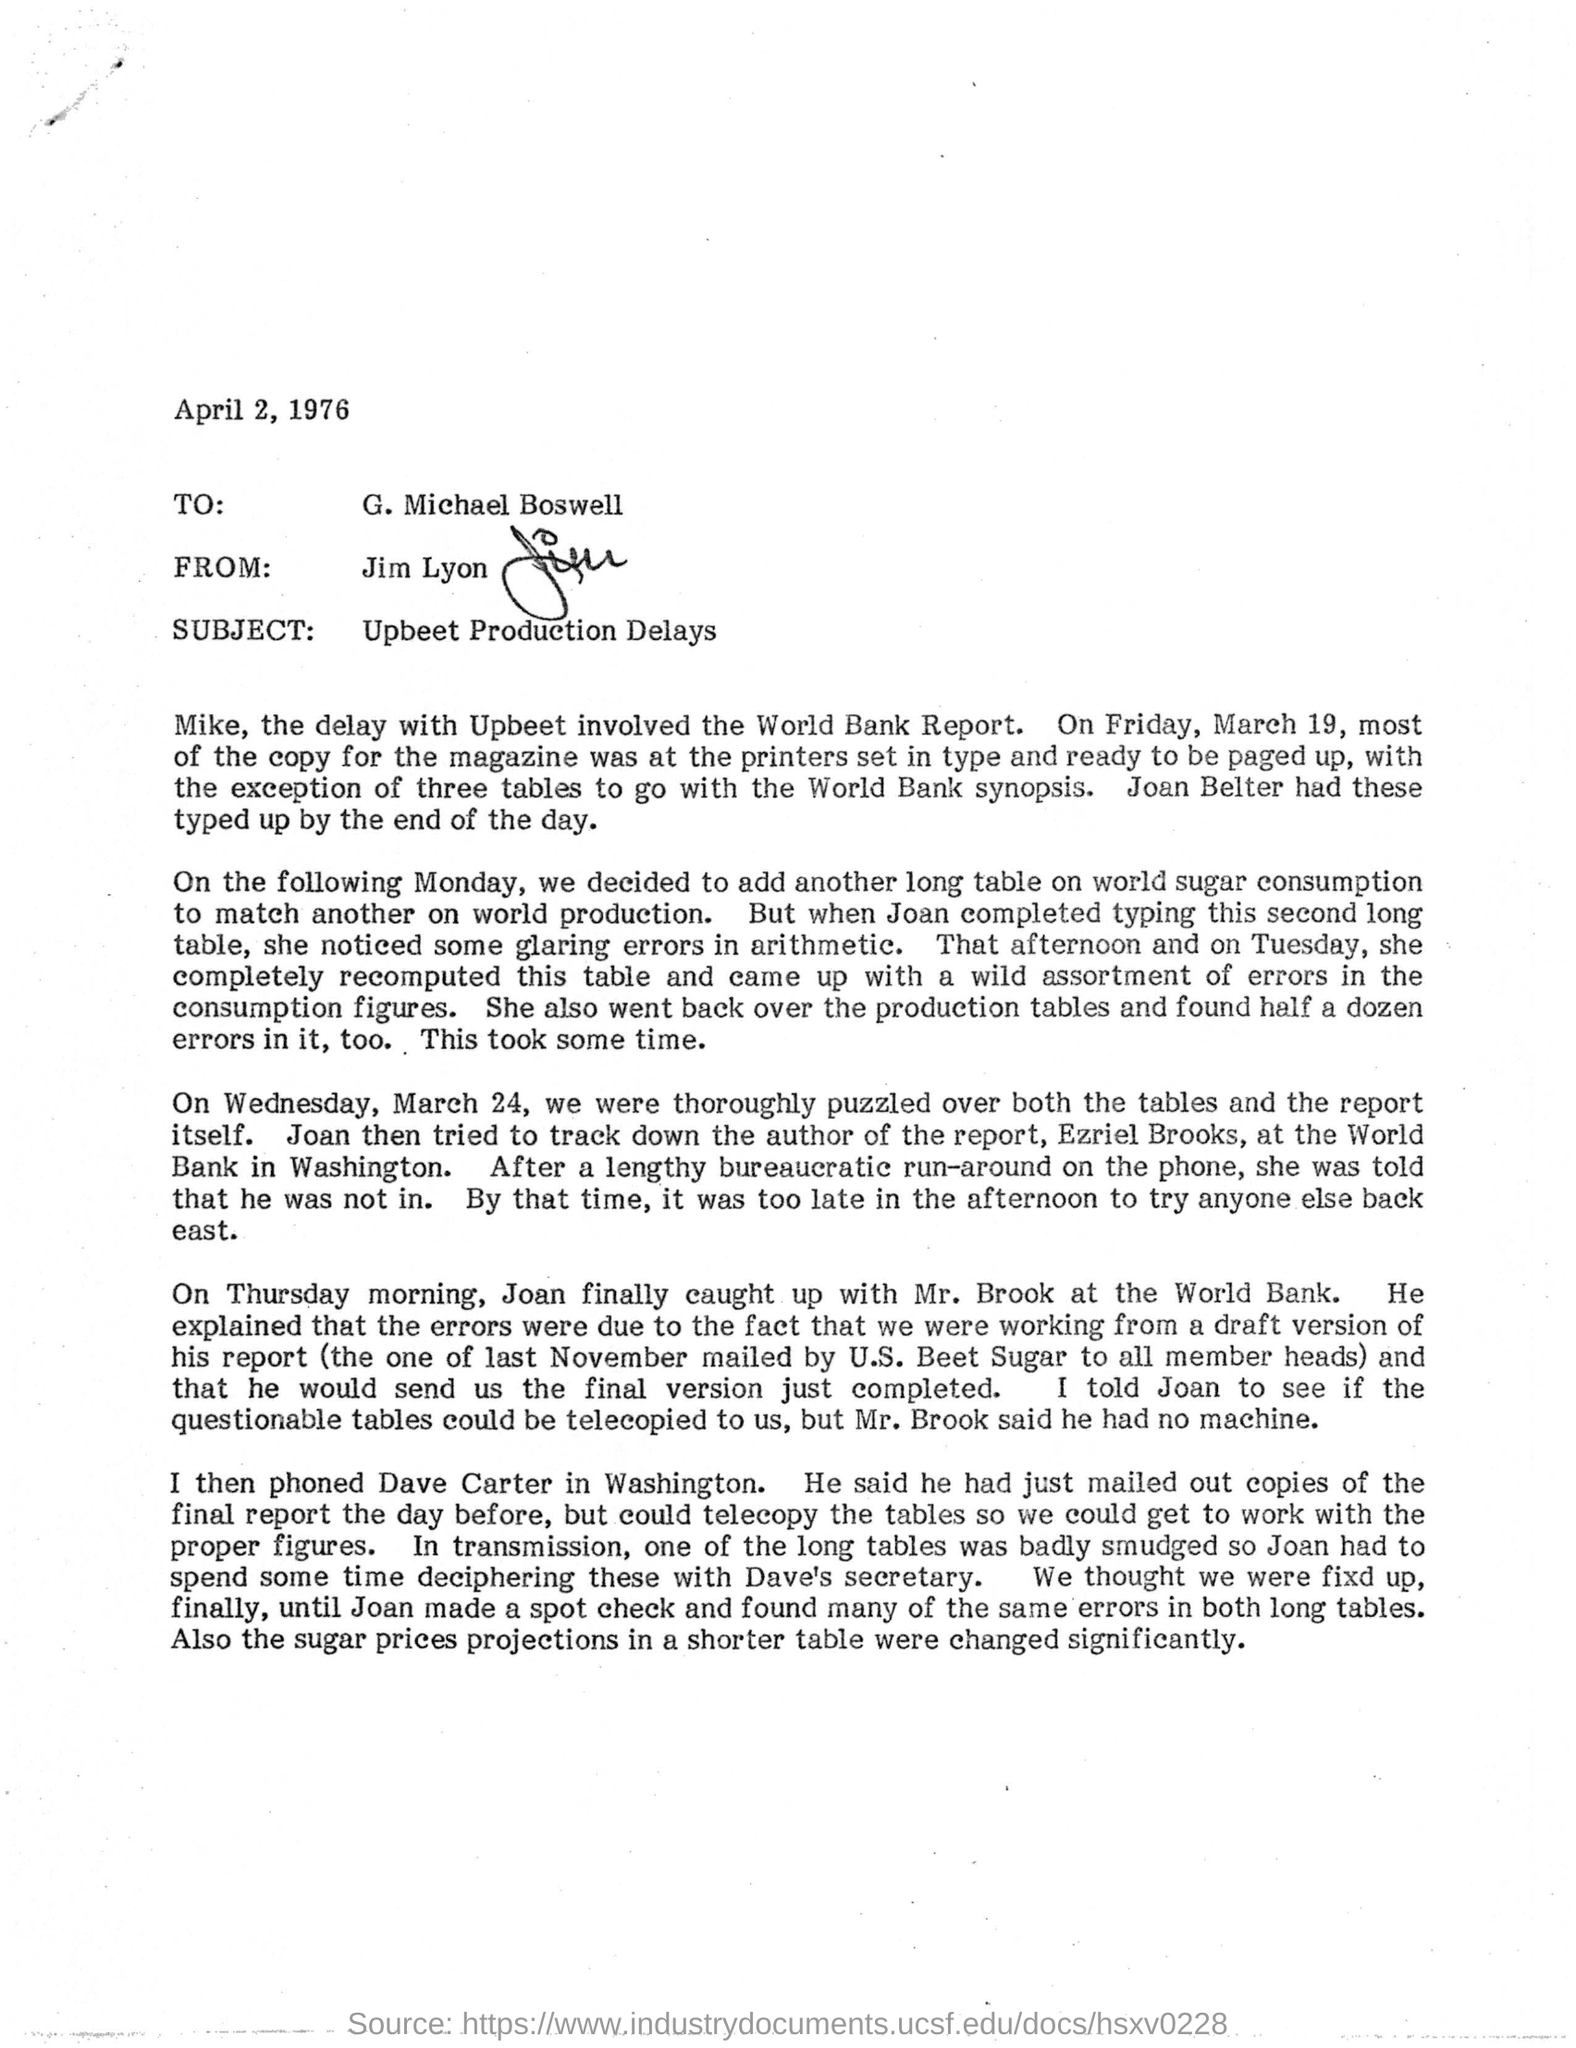Can you tell me more about the main issue discussed in this letter? The letter discusses delays in the production of an article regarding the World Bank Report. It specifically mentions errors found in some production tables and arithmetic, which were significant enough to impact the final output of the magazine. Were there any specific reasons mentioned for these errors? Yes, the letter mentions that the errors were partly due to the fact that they were working from a draft version of the World Bank report. It also noted that issues like smudged tables made it difficult to get accurate information, which needed to be rectified by cross-checking with original documents. 